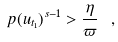<formula> <loc_0><loc_0><loc_500><loc_500>\ p ( u _ { t _ { 1 } } ) ^ { s - 1 } > \frac { \eta } { \varpi } \ ,</formula> 